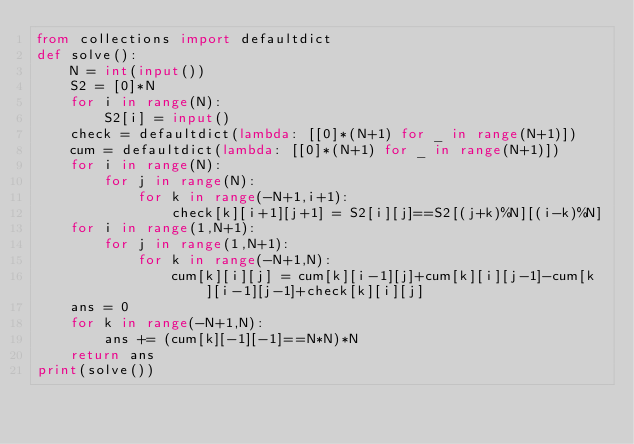Convert code to text. <code><loc_0><loc_0><loc_500><loc_500><_Python_>from collections import defaultdict
def solve():
    N = int(input())
    S2 = [0]*N
    for i in range(N):
        S2[i] = input()
    check = defaultdict(lambda: [[0]*(N+1) for _ in range(N+1)])
    cum = defaultdict(lambda: [[0]*(N+1) for _ in range(N+1)])
    for i in range(N):
        for j in range(N):
            for k in range(-N+1,i+1):
                check[k][i+1][j+1] = S2[i][j]==S2[(j+k)%N][(i-k)%N]
    for i in range(1,N+1):
        for j in range(1,N+1):
            for k in range(-N+1,N):
                cum[k][i][j] = cum[k][i-1][j]+cum[k][i][j-1]-cum[k][i-1][j-1]+check[k][i][j]
    ans = 0
    for k in range(-N+1,N):
        ans += (cum[k][-1][-1]==N*N)*N
    return ans
print(solve())</code> 